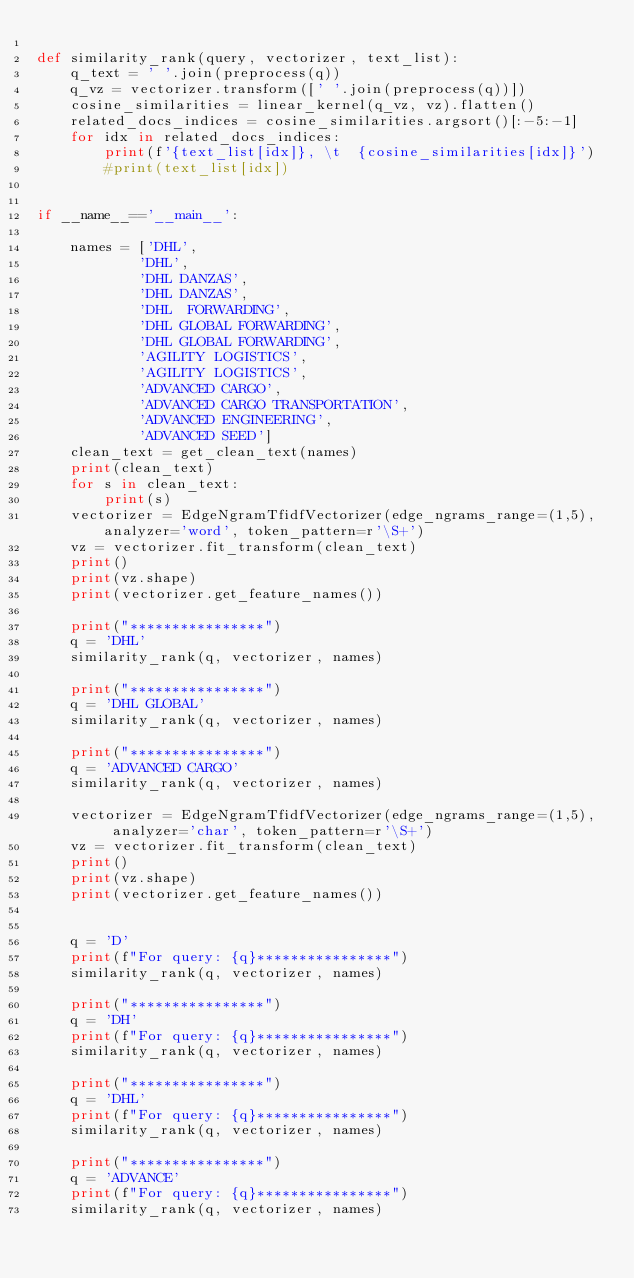Convert code to text. <code><loc_0><loc_0><loc_500><loc_500><_Python_>
def similarity_rank(query, vectorizer, text_list):
    q_text = ' '.join(preprocess(q))
    q_vz = vectorizer.transform([' '.join(preprocess(q))])
    cosine_similarities = linear_kernel(q_vz, vz).flatten()
    related_docs_indices = cosine_similarities.argsort()[:-5:-1]
    for idx in related_docs_indices:
        print(f'{text_list[idx]}, \t  {cosine_similarities[idx]}')
        #print(text_list[idx])


if __name__=='__main__':
  
    names = ['DHL', 	  
            'DHL', 	  
            'DHL DANZAS', 	
            'DHL DANZAS', 	  
            'DHL  FORWARDING', 	 
            'DHL GLOBAL FORWARDING', 	  
            'DHL GLOBAL FORWARDING',
            'AGILITY LOGISTICS', 	  
            'AGILITY LOGISTICS',
            'ADVANCED CARGO', 	  
            'ADVANCED CARGO TRANSPORTATION', 	  
            'ADVANCED ENGINEERING', 	  
            'ADVANCED SEED']
    clean_text = get_clean_text(names)
    print(clean_text)
    for s in clean_text:
        print(s)
    vectorizer = EdgeNgramTfidfVectorizer(edge_ngrams_range=(1,5), analyzer='word', token_pattern=r'\S+')
    vz = vectorizer.fit_transform(clean_text)
    print()
    print(vz.shape)
    print(vectorizer.get_feature_names())

    print("****************")
    q = 'DHL'
    similarity_rank(q, vectorizer, names)

    print("****************")
    q = 'DHL GLOBAL'
    similarity_rank(q, vectorizer, names)

    print("****************")
    q = 'ADVANCED CARGO'
    similarity_rank(q, vectorizer, names)

    vectorizer = EdgeNgramTfidfVectorizer(edge_ngrams_range=(1,5),  analyzer='char', token_pattern=r'\S+')
    vz = vectorizer.fit_transform(clean_text)
    print()
    print(vz.shape)
    print(vectorizer.get_feature_names())

   
    q = 'D'
    print(f"For query: {q}****************")
    similarity_rank(q, vectorizer, names)

    print("****************")
    q = 'DH'
    print(f"For query: {q}****************")
    similarity_rank(q, vectorizer, names)

    print("****************")
    q = 'DHL'
    print(f"For query: {q}****************")
    similarity_rank(q, vectorizer, names)

    print("****************")
    q = 'ADVANCE'
    print(f"For query: {q}****************")
    similarity_rank(q, vectorizer, names)




</code> 